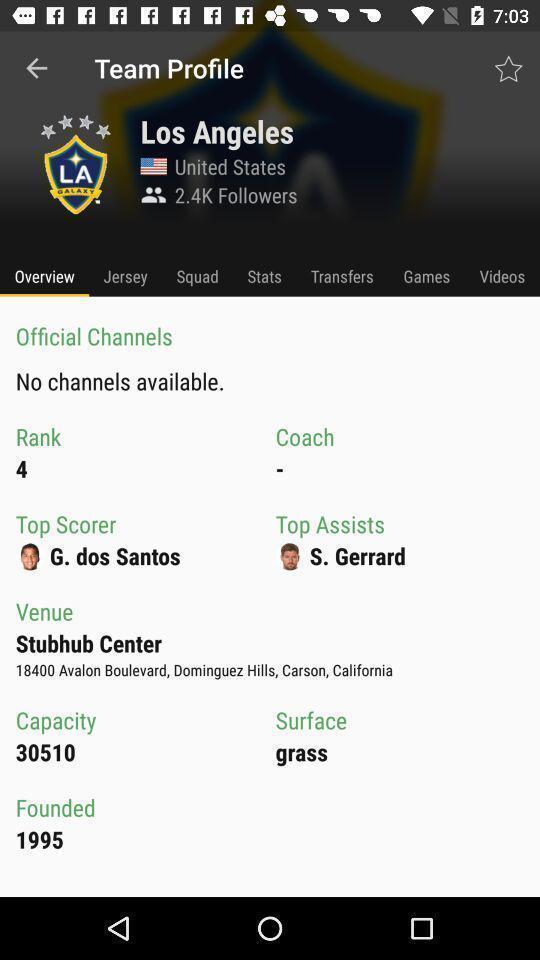Provide a description of this screenshot. Page showing team profile. 